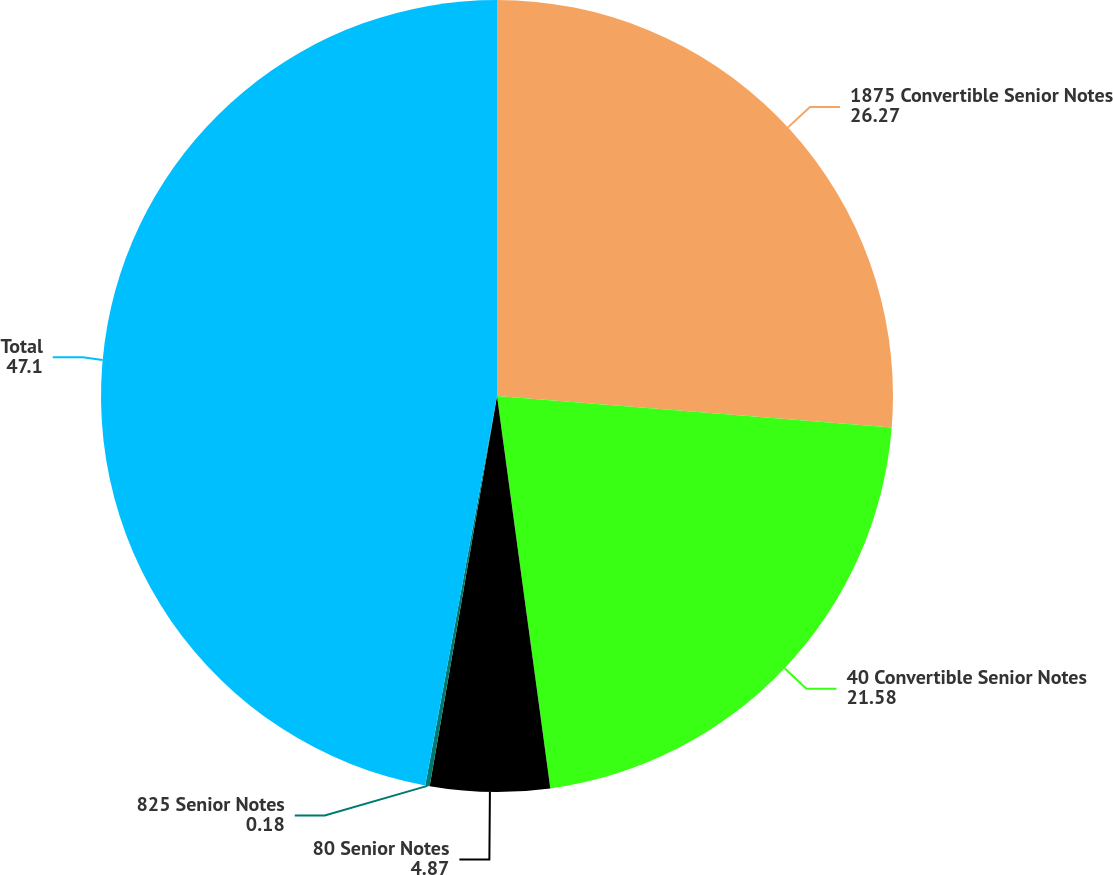Convert chart to OTSL. <chart><loc_0><loc_0><loc_500><loc_500><pie_chart><fcel>1875 Convertible Senior Notes<fcel>40 Convertible Senior Notes<fcel>80 Senior Notes<fcel>825 Senior Notes<fcel>Total<nl><fcel>26.27%<fcel>21.58%<fcel>4.87%<fcel>0.18%<fcel>47.1%<nl></chart> 